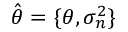<formula> <loc_0><loc_0><loc_500><loc_500>\hat { \theta } = \{ \theta , \sigma _ { n } ^ { 2 } \}</formula> 